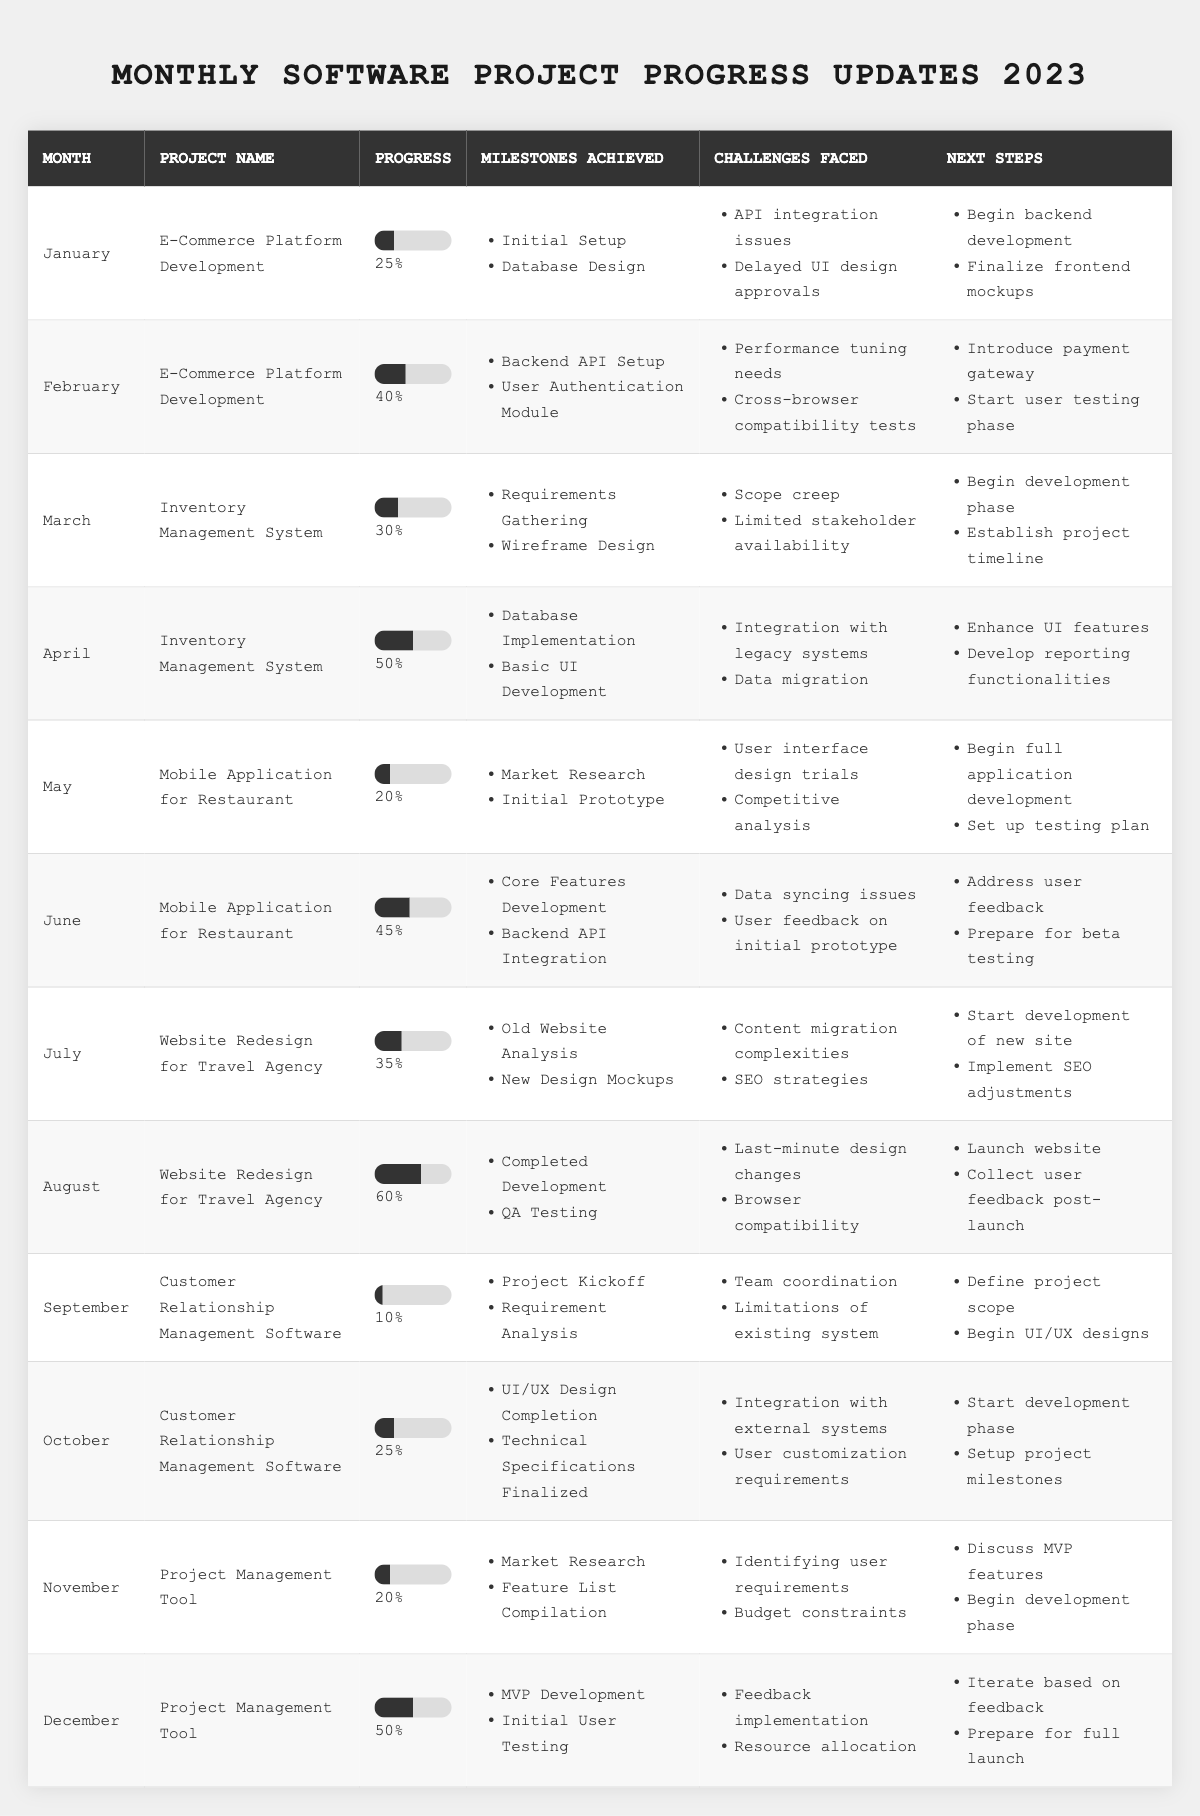What is the progress percentage for the "E-Commerce Platform Development" project in February? In February, the progress listed for the "E-Commerce Platform Development" project is 40%.
Answer: 40% Which month had the highest project progress and what was that progress? In August, the "Website Redesign for Travel Agency" project had the highest progress of 60%.
Answer: 60% Did the "Mobile Application for Restaurant" project face any challenges in June? Yes, the "Mobile Application for Restaurant" project faced data syncing issues and user feedback on initial prototype in June.
Answer: Yes What are the next steps for the "Inventory Management System" project in April? The next steps for the "Inventory Management System" in April include enhancing UI features and developing reporting functionalities.
Answer: Enhance UI features, develop reporting functionalities What is the difference in progress percentage between "Customer Relationship Management Software" in September and December? The progress in September is 10% and in December it is 50%. The difference is 50% - 10% = 40%.
Answer: 40% Which project achieved milestones in both March and April, and what were the milestones for April? The "Inventory Management System" project achieved milestones in both March and April. In April, the milestones were Database Implementation and Basic UI Development.
Answer: Inventory Management System; Database Implementation, Basic UI Development How many projects had their progress above 50% by the end of 2023? By the end of 2023, two projects had progress above 50%: "Website Redesign for Travel Agency" at 60% and "Project Management Tool" at 50%, resulting in a total of 2 projects.
Answer: 2 In which month was the "Project Management Tool" initially launched, and what was its progress at that time? The "Project Management Tool" was initially launched in November with a progress of 20%.
Answer: November; 20% What was the lowest progress percentage recorded in the table, and for which project? The lowest progress percentage recorded was 10% for the "Customer Relationship Management Software" project in September.
Answer: 10%; Customer Relationship Management Software Which project had the most challenges listed in its progress update for October? The "Customer Relationship Management Software" project had two challenges listed in its progress update for October: integration with external systems and user customization requirements.
Answer: Customer Relationship Management Software What are the total number of challenges faced by the "E-Commerce Platform Development" project across January and February? In January, the project faced 2 challenges, and in February it faced another 2 challenges, totaling to 4 challenges across both months.
Answer: 4 